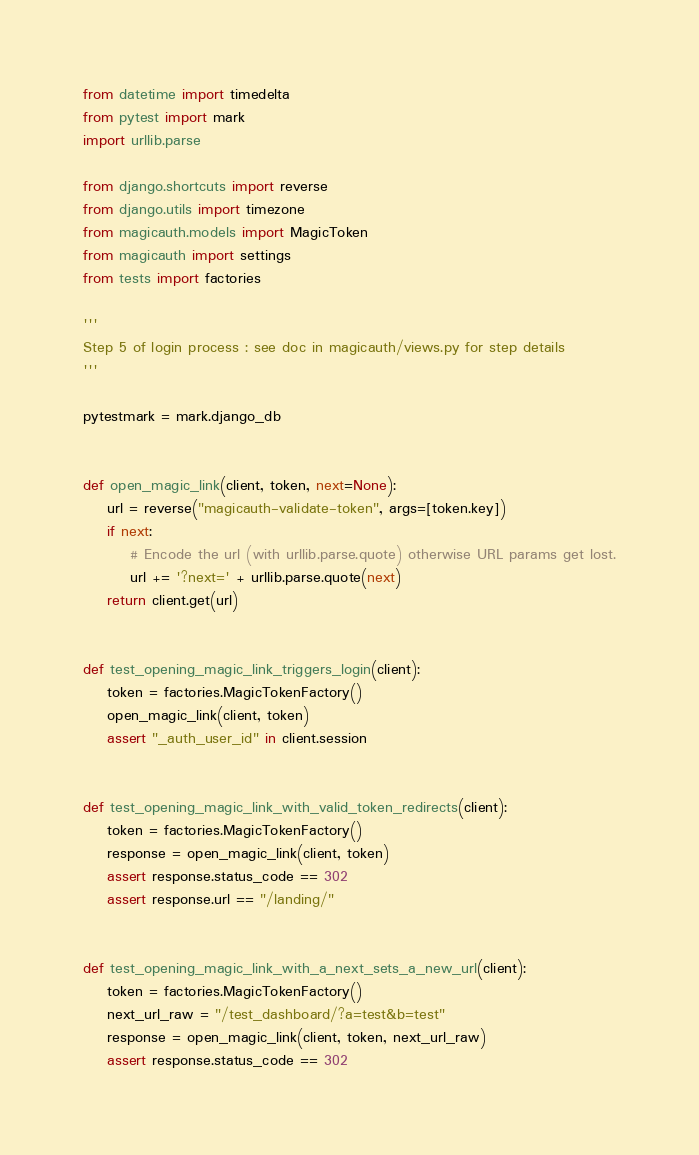Convert code to text. <code><loc_0><loc_0><loc_500><loc_500><_Python_>from datetime import timedelta
from pytest import mark
import urllib.parse

from django.shortcuts import reverse
from django.utils import timezone
from magicauth.models import MagicToken
from magicauth import settings
from tests import factories

'''
Step 5 of login process : see doc in magicauth/views.py for step details
'''

pytestmark = mark.django_db


def open_magic_link(client, token, next=None):
    url = reverse("magicauth-validate-token", args=[token.key])
    if next:
        # Encode the url (with urllib.parse.quote) otherwise URL params get lost.
        url += '?next=' + urllib.parse.quote(next)
    return client.get(url)


def test_opening_magic_link_triggers_login(client):
    token = factories.MagicTokenFactory()
    open_magic_link(client, token)
    assert "_auth_user_id" in client.session


def test_opening_magic_link_with_valid_token_redirects(client):
    token = factories.MagicTokenFactory()
    response = open_magic_link(client, token)
    assert response.status_code == 302
    assert response.url == "/landing/"


def test_opening_magic_link_with_a_next_sets_a_new_url(client):
    token = factories.MagicTokenFactory()
    next_url_raw = "/test_dashboard/?a=test&b=test"
    response = open_magic_link(client, token, next_url_raw)
    assert response.status_code == 302</code> 